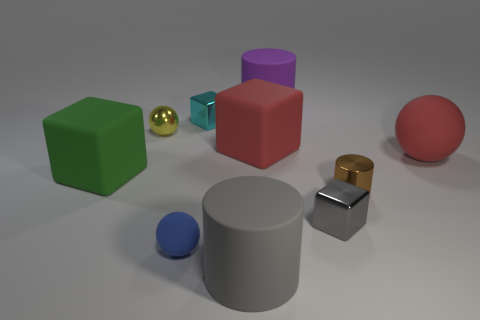The matte thing that is the same color as the large matte ball is what shape?
Your answer should be compact. Cube. There is a metal block that is on the left side of the cylinder behind the large ball; what size is it?
Offer a terse response. Small. Is there any other thing of the same color as the small matte thing?
Your answer should be very brief. No. Are the cube on the left side of the small cyan metal object and the large red thing left of the red sphere made of the same material?
Your answer should be very brief. Yes. What material is the large object that is to the right of the big red block and in front of the tiny yellow metal object?
Give a very brief answer. Rubber. Does the green matte object have the same shape as the large matte object that is behind the tiny cyan shiny object?
Offer a terse response. No. What material is the big cylinder in front of the matte block that is in front of the rubber ball that is behind the gray metallic cube?
Give a very brief answer. Rubber. What number of other things are the same size as the metal cylinder?
Offer a very short reply. 4. Is the small rubber object the same color as the small metal sphere?
Ensure brevity in your answer.  No. What number of cubes are behind the tiny sphere that is behind the rubber cube on the left side of the big gray cylinder?
Your answer should be compact. 1. 